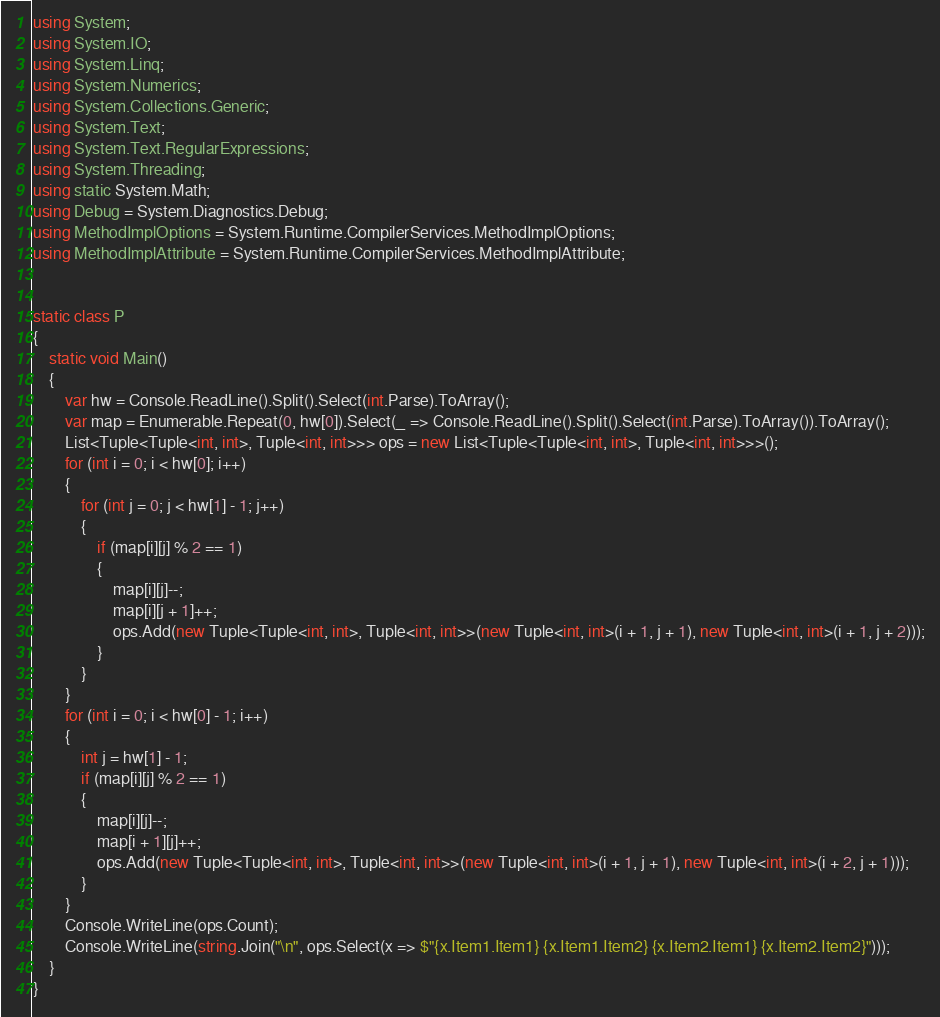Convert code to text. <code><loc_0><loc_0><loc_500><loc_500><_C#_>using System;
using System.IO;
using System.Linq;
using System.Numerics;
using System.Collections.Generic;
using System.Text;
using System.Text.RegularExpressions;
using System.Threading;
using static System.Math;
using Debug = System.Diagnostics.Debug;
using MethodImplOptions = System.Runtime.CompilerServices.MethodImplOptions;
using MethodImplAttribute = System.Runtime.CompilerServices.MethodImplAttribute;


static class P
{
    static void Main()
    {
        var hw = Console.ReadLine().Split().Select(int.Parse).ToArray();
        var map = Enumerable.Repeat(0, hw[0]).Select(_ => Console.ReadLine().Split().Select(int.Parse).ToArray()).ToArray();
        List<Tuple<Tuple<int, int>, Tuple<int, int>>> ops = new List<Tuple<Tuple<int, int>, Tuple<int, int>>>();
        for (int i = 0; i < hw[0]; i++)
        {
            for (int j = 0; j < hw[1] - 1; j++)
            {
                if (map[i][j] % 2 == 1)
                {
                    map[i][j]--;
                    map[i][j + 1]++;
                    ops.Add(new Tuple<Tuple<int, int>, Tuple<int, int>>(new Tuple<int, int>(i + 1, j + 1), new Tuple<int, int>(i + 1, j + 2)));
                }
            }
        }
        for (int i = 0; i < hw[0] - 1; i++)
        {
            int j = hw[1] - 1;
            if (map[i][j] % 2 == 1)
            {
                map[i][j]--;
                map[i + 1][j]++;
                ops.Add(new Tuple<Tuple<int, int>, Tuple<int, int>>(new Tuple<int, int>(i + 1, j + 1), new Tuple<int, int>(i + 2, j + 1)));
            }
        }
        Console.WriteLine(ops.Count);
        Console.WriteLine(string.Join("\n", ops.Select(x => $"{x.Item1.Item1} {x.Item1.Item2} {x.Item2.Item1} {x.Item2.Item2}")));
    }
}</code> 